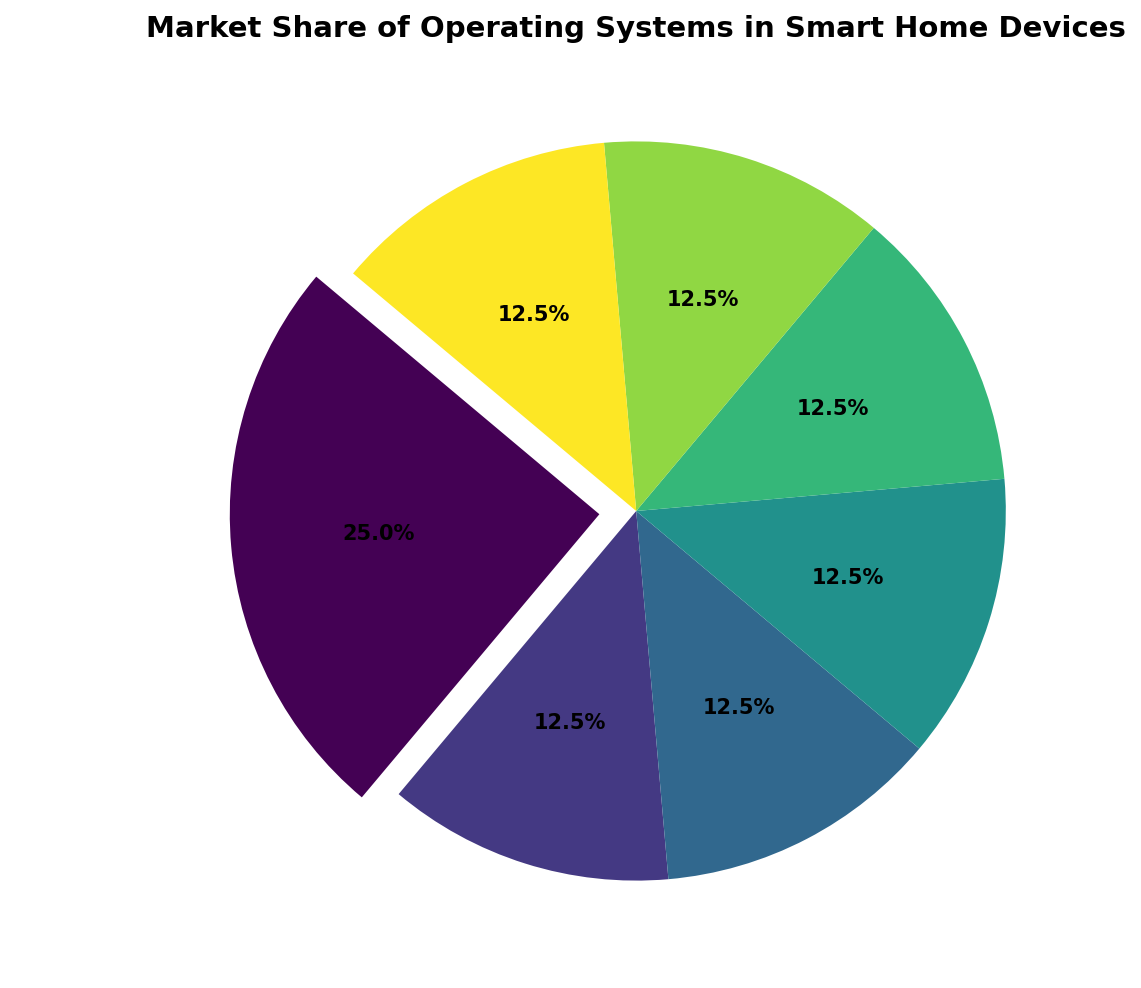What is the operating system with the highest market share? The pie chart has an exploded section, which indicates the operating system with the highest market share. In this case, the exploded section corresponds to Windows IoT, which has a 10% market share.
Answer: Windows IoT Which operating systems have equal market share according to the pie chart? By observing the pie chart, we can see that FreeRTOS, ThreadX, Contiki, RIOT, Zephyr, and Other each have an equal market share of 5%.
Answer: FreeRTOS, ThreadX, Contiki, RIOT, Zephyr, Other What is the total market share of all operating systems other than Windows IoT? Windows IoT has a market share of 10%. The total market share is 100%. Therefore, the total market share of the other operating systems is 100% - 10% = 90%.
Answer: 90% How much larger is the market share of Windows IoT compared to FreeRTOS? Windows IoT has a market share of 10% and FreeRTOS has a market share of 5%. The difference between them is 10% - 5% = 5%.
Answer: 5% Which operating system segments are visually the same size in the pie chart? By examining the pie chart, we can see that the segments for FreeRTOS, ThreadX, Contiki, RIOT, Zephyr, and Other are all the same size, each representing 5% market share.
Answer: FreeRTOS, ThreadX, Contiki, RIOT, Zephyr, Other What is the combined market share of Contiki and RIOT? Contiki has a market share of 5% and RIOT also has a market share of 5%. Adding them together, the combined market share is 5% + 5% = 10%.
Answer: 10% Which two operating systems together account for a market share greater than Windows IoT's share? Windows IoT has a market share of 10%. Combining any two operating systems with each having a 5% share (like FreeRTOS and ThreadX, for instance), equals 5% + 5% = 10%, which is not greater. If we combine three such operating systems, we get 5% + 5% + 5% = 15%, which is greater. However, the question specifies "two" operating systems.
Answer: None What percentage of the total market share do the smallest segments represent? The smallest segments are FreeRTOS, ThreadX, Contiki, RIOT, Zephyr, and Other, each with a 5% share. Their total percentage is 6 segments * 5% = 30%.
Answer: 30% 